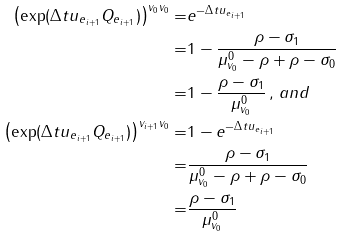Convert formula to latex. <formula><loc_0><loc_0><loc_500><loc_500>\left ( \exp ( \Delta t u _ { e _ { i + 1 } } Q _ { e _ { i + 1 } } ) \right ) ^ { v _ { 0 } v _ { 0 } } = & e ^ { - \Delta t u _ { e _ { i + 1 } } } \\ = & 1 - \frac { \rho - \sigma _ { 1 } } { \mu ^ { 0 } _ { v _ { 0 } } - \rho + \rho - \sigma _ { 0 } } \\ = & 1 - \frac { \rho - \sigma _ { 1 } } { \mu ^ { 0 } _ { v _ { 0 } } } \, , \, a n d \\ \left ( \exp ( \Delta t u _ { e _ { i + 1 } } Q _ { e _ { i + 1 } } ) \right ) ^ { v _ { i + 1 } v _ { 0 } } = & 1 - e ^ { - \Delta t u _ { e _ { i + 1 } } } \\ = & \frac { \rho - \sigma _ { 1 } } { \mu ^ { 0 } _ { v _ { 0 } } - \rho + \rho - \sigma _ { 0 } } \\ = & \frac { \rho - \sigma _ { 1 } } { \mu ^ { 0 } _ { v _ { 0 } } }</formula> 